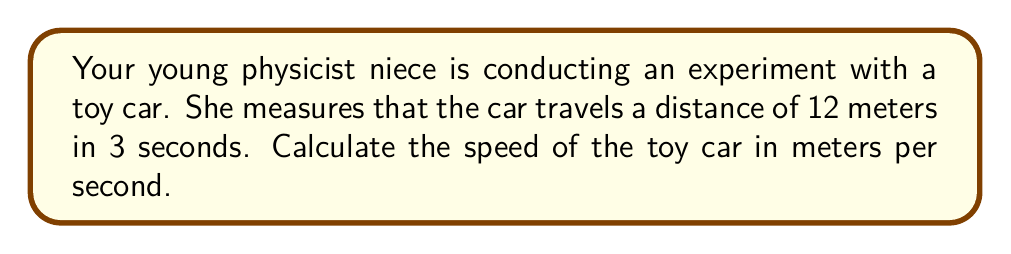Provide a solution to this math problem. To calculate the speed of an object, we use the formula:

$$\text{Speed} = \frac{\text{Distance}}{\text{Time}}$$

Given:
- Distance traveled = 12 meters
- Time taken = 3 seconds

Let's substitute these values into the formula:

$$\text{Speed} = \frac{12 \text{ meters}}{3 \text{ seconds}}$$

Now, we perform the division:

$$\text{Speed} = 4 \text{ meters per second}$$

This means the toy car is traveling at a speed of 4 meters per second.
Answer: $4 \text{ m/s}$ 